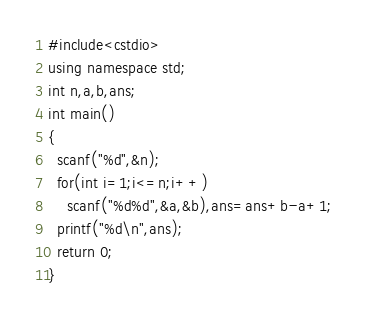<code> <loc_0><loc_0><loc_500><loc_500><_C++_>#include<cstdio>
using namespace std;
int n,a,b,ans;
int main()
{
  scanf("%d",&n);
  for(int i=1;i<=n;i++)
    scanf("%d%d",&a,&b),ans=ans+b-a+1;
  printf("%d\n",ans);
  return 0;
}</code> 